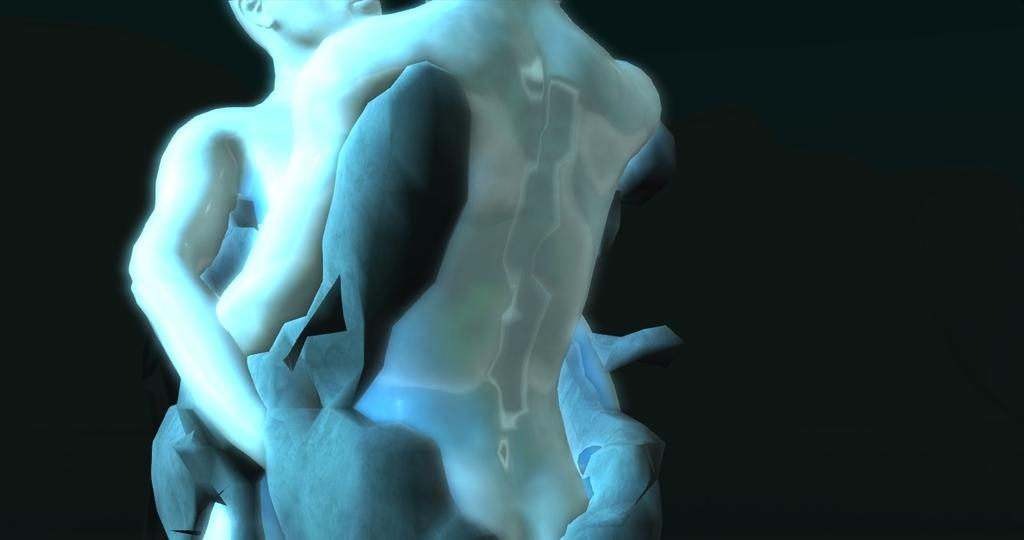What type of art is depicted in the image? There are sculptures in the image. Can you describe the sculptures in more detail? Unfortunately, the facts provided do not offer any additional details about the sculptures. Are the sculptures made of a specific material or in a particular style? The facts provided do not offer any information about the material or style of the sculptures. What type of railway is visible in the image? There is no railway present in the image; it only features sculptures. What kind of joke can be seen being told by the sculptures in the image? There is no joke being depicted in the image, as it only features sculptures. 